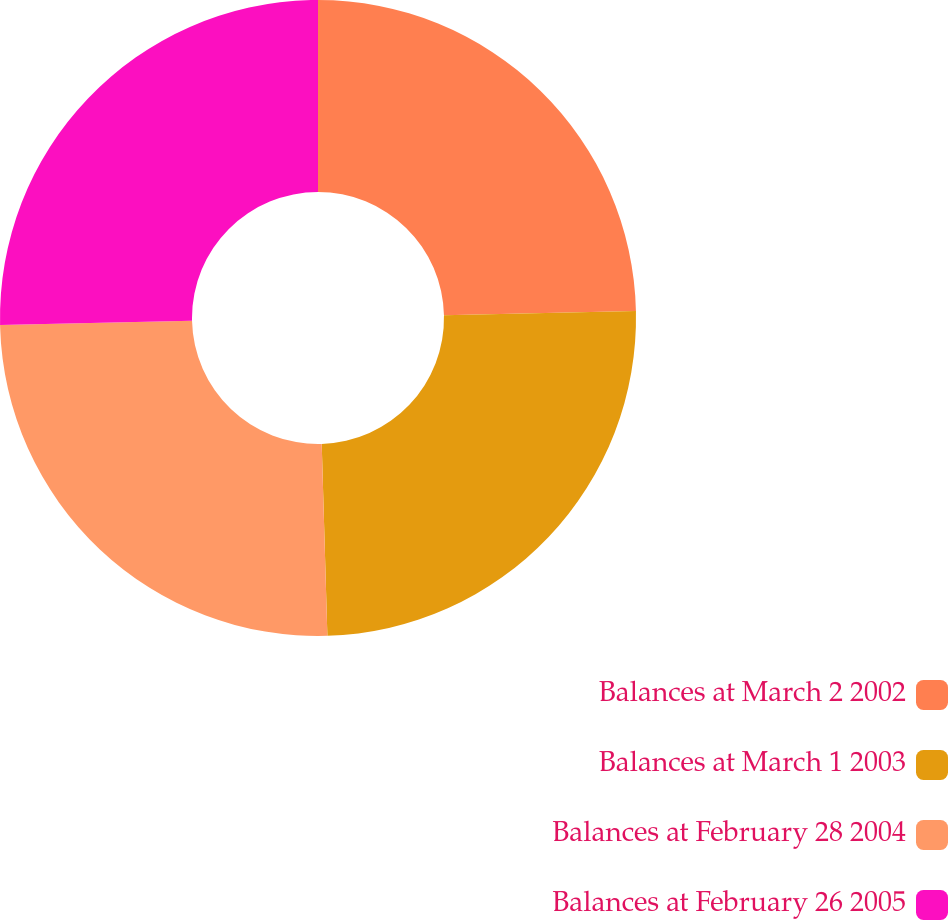Convert chart. <chart><loc_0><loc_0><loc_500><loc_500><pie_chart><fcel>Balances at March 2 2002<fcel>Balances at March 1 2003<fcel>Balances at February 28 2004<fcel>Balances at February 26 2005<nl><fcel>24.65%<fcel>24.88%<fcel>25.12%<fcel>25.35%<nl></chart> 